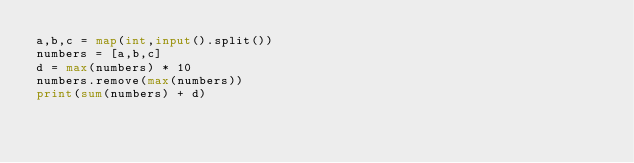Convert code to text. <code><loc_0><loc_0><loc_500><loc_500><_Python_>a,b,c = map(int,input().split())
numbers = [a,b,c]
d = max(numbers) * 10
numbers.remove(max(numbers))
print(sum(numbers) + d)</code> 